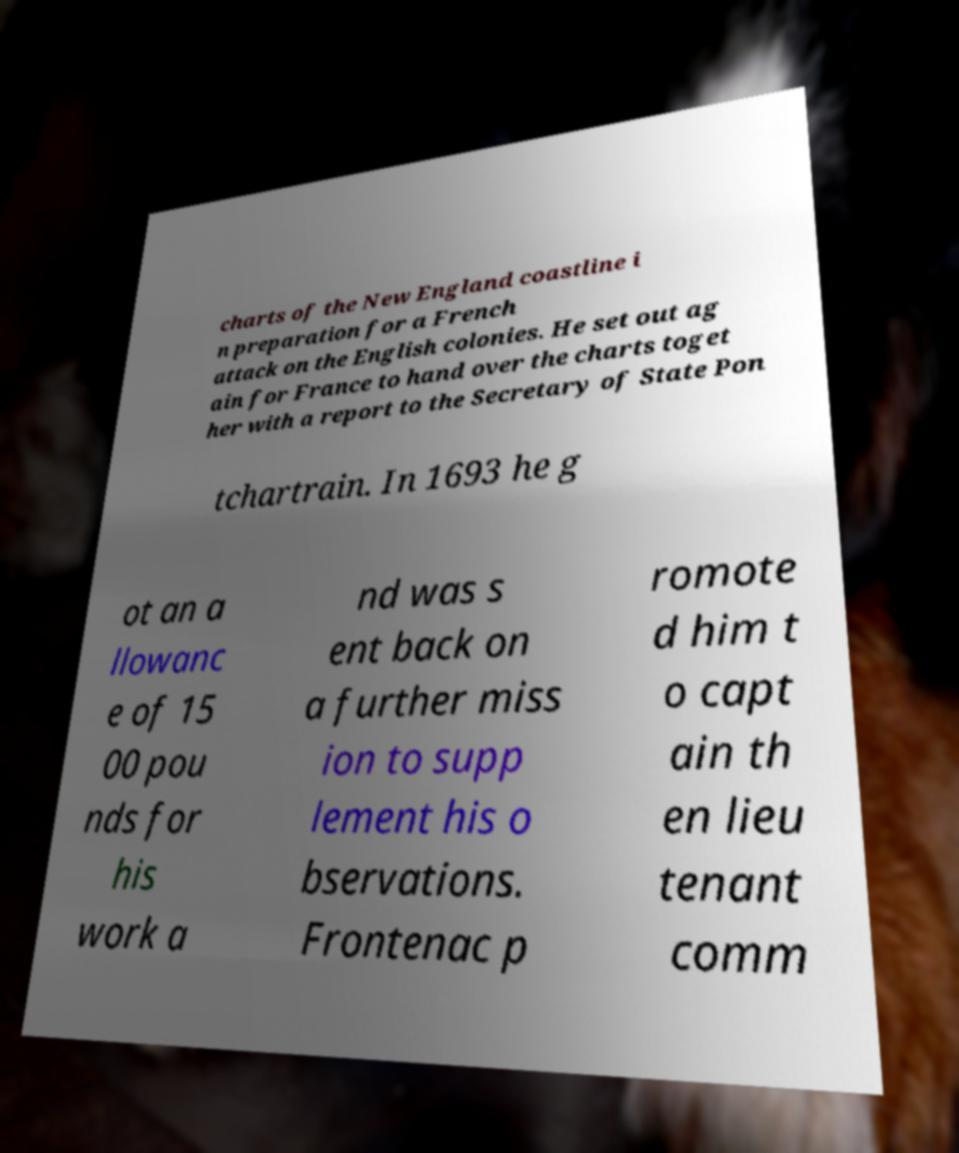There's text embedded in this image that I need extracted. Can you transcribe it verbatim? charts of the New England coastline i n preparation for a French attack on the English colonies. He set out ag ain for France to hand over the charts toget her with a report to the Secretary of State Pon tchartrain. In 1693 he g ot an a llowanc e of 15 00 pou nds for his work a nd was s ent back on a further miss ion to supp lement his o bservations. Frontenac p romote d him t o capt ain th en lieu tenant comm 